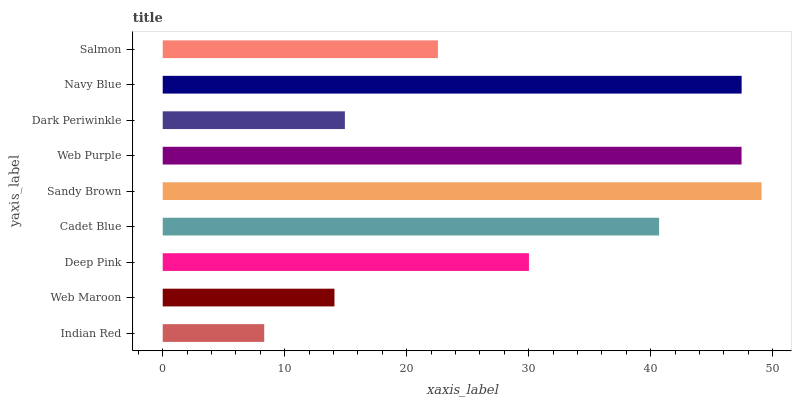Is Indian Red the minimum?
Answer yes or no. Yes. Is Sandy Brown the maximum?
Answer yes or no. Yes. Is Web Maroon the minimum?
Answer yes or no. No. Is Web Maroon the maximum?
Answer yes or no. No. Is Web Maroon greater than Indian Red?
Answer yes or no. Yes. Is Indian Red less than Web Maroon?
Answer yes or no. Yes. Is Indian Red greater than Web Maroon?
Answer yes or no. No. Is Web Maroon less than Indian Red?
Answer yes or no. No. Is Deep Pink the high median?
Answer yes or no. Yes. Is Deep Pink the low median?
Answer yes or no. Yes. Is Web Maroon the high median?
Answer yes or no. No. Is Salmon the low median?
Answer yes or no. No. 